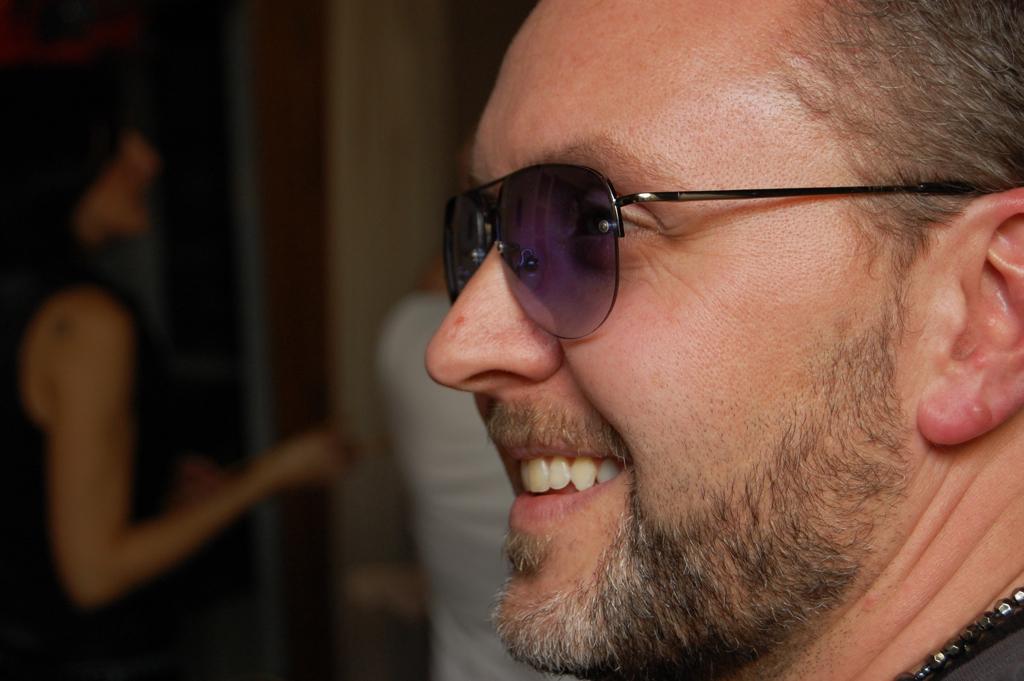In one or two sentences, can you explain what this image depicts? In this image on the foreground we can see there is a man smiling and wearing a glass. 